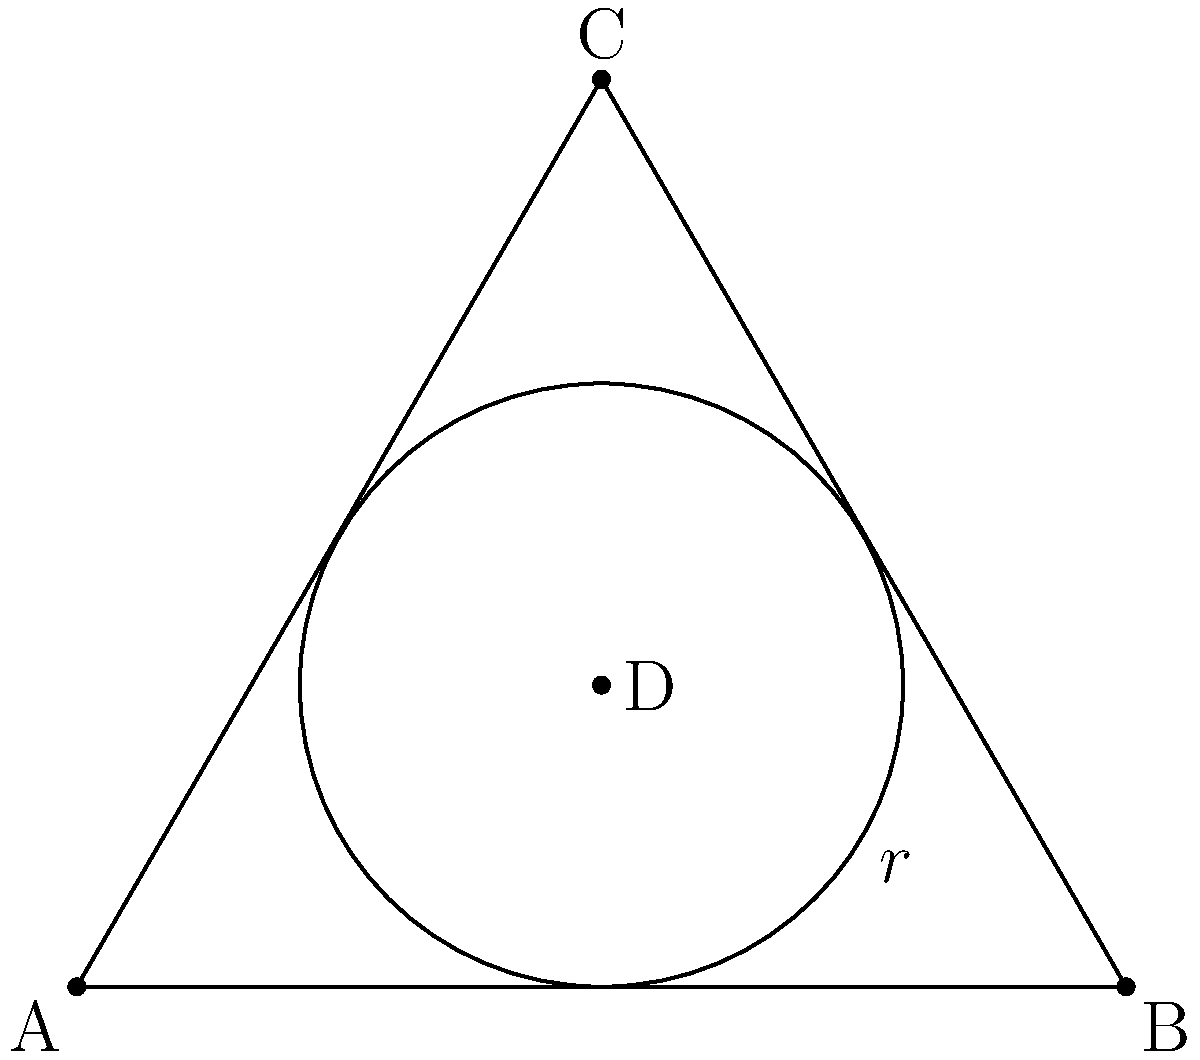In materials science, efficient packing of atoms is crucial for understanding crystal structures. Consider an equilateral triangle ABC with side length 4 units. A circle is inscribed within this triangle, touching all three sides. Calculate the radius of this inscribed circle to three decimal places. How does this relate to the concept of atomic packing factor (APF) in crystalline structures? Let's approach this step-by-step:

1) For an equilateral triangle with side length $a$, the radius $r$ of the inscribed circle is given by:

   $$r = \frac{a}{2\sqrt{3}}$$

2) In our case, $a = 4$. Substituting this:

   $$r = \frac{4}{2\sqrt{3}} = \frac{2}{\sqrt{3}}$$

3) To calculate this:
   
   $$r = \frac{2}{\sqrt{3}} \approx 1.155$$

4) Rounding to three decimal places: $r = 1.155$ units

5) Relation to Atomic Packing Factor (APF):
   - APF is the fraction of volume in a crystal structure occupied by atoms.
   - In 2D, this circle represents an atom, and the triangle represents the unit cell.
   - The ratio of the circle's area to the triangle's area is analogous to APF in 3D structures.
   - Higher APF indicates more efficient packing, which often correlates with higher density and stability in materials.

6) To calculate 2D APF:
   - Area of circle: $A_c = \pi r^2 \approx 4.189$ sq units
   - Area of triangle: $A_t = \frac{\sqrt{3}}{4}a^2 = 6.928$ sq units
   - 2D APF = $\frac{A_c}{A_t} \approx 0.605$ or 60.5%

This 2D packing efficiency is analogous to the APF of a body-centered cubic (BCC) structure in 3D, which has an APF of about 68%.
Answer: $r = 1.155$ units; relates to APF by representing 2D packing efficiency (60.5%), analogous to 3D crystal structures. 